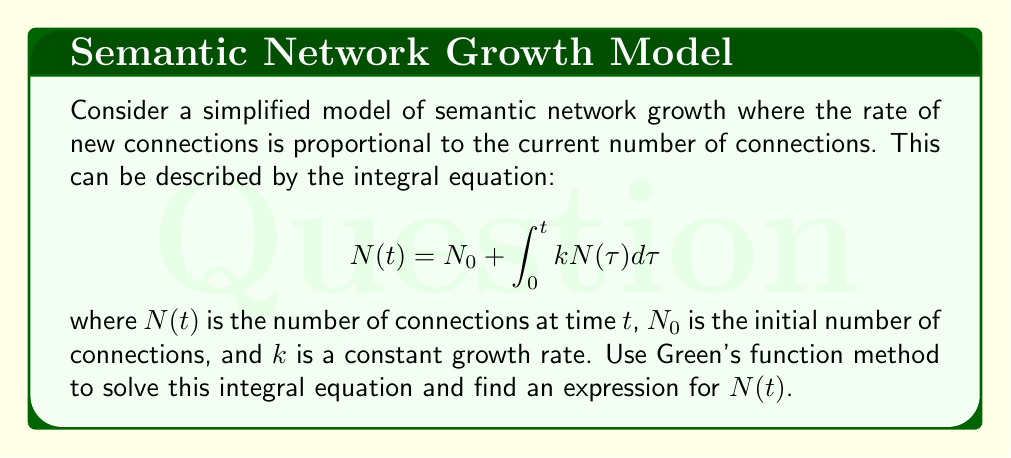What is the answer to this math problem? To solve this integral equation using Green's function method, we follow these steps:

1) First, we need to convert the integral equation into a differential equation. Differentiate both sides with respect to $t$:

   $$\frac{dN}{dt} = k N(t)$$

2) This is a first-order linear differential equation. The corresponding homogeneous equation is:

   $$\frac{dN}{dt} - k N = 0$$

3) The Green's function $G(t,\tau)$ for this equation satisfies:

   $$\frac{\partial G}{\partial t} - k G = \delta(t-\tau)$$

   where $\delta(t-\tau)$ is the Dirac delta function.

4) The solution for $G(t,\tau)$ is:

   $$G(t,\tau) = e^{k(t-\tau)} H(t-\tau)$$

   where $H(t-\tau)$ is the Heaviside step function.

5) The general solution using Green's function is:

   $$N(t) = N_0 e^{kt} + \int_0^t G(t,\tau) f(\tau) d\tau$$

   where $f(\tau)$ is the non-homogeneous term (in this case, $f(\tau) = 0$).

6) Substituting the Green's function and simplifying:

   $$N(t) = N_0 e^{kt} + 0$$

7) Therefore, the final solution is:

   $$N(t) = N_0 e^{kt}$$

This expression shows that the number of connections in the semantic network grows exponentially with time, which is consistent with the model's assumption that growth rate is proportional to the current number of connections.
Answer: $N(t) = N_0 e^{kt}$ 